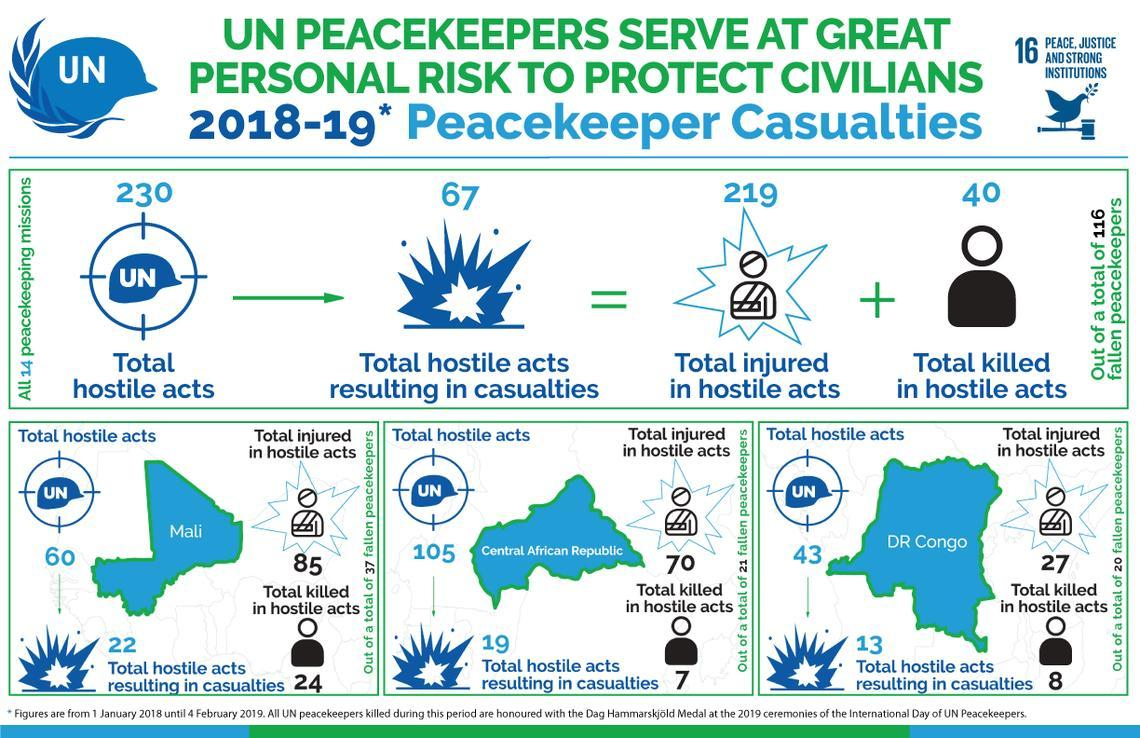In which place did a total of 22 hostile acts resulting in casualties take place?
Answer the question with a short phrase. Mali How many were injured in hostile acts in Congo? 27 What is the total number of people killed in hostile acts? 40 Out of a total 230 hostile acts, how many resulted in casualties? 67 In which place was the number of deaths due to hostile acts highest? Mali How many were injured in hostile acts in Mali? 85 How many were killed in hostile acts in Congo? 8 How many total hostile acts took place in Central African Republic? 105 How many people in total were injured in hostile acts? 219 How many were killed in hostile acts in Central African Republic? 7 